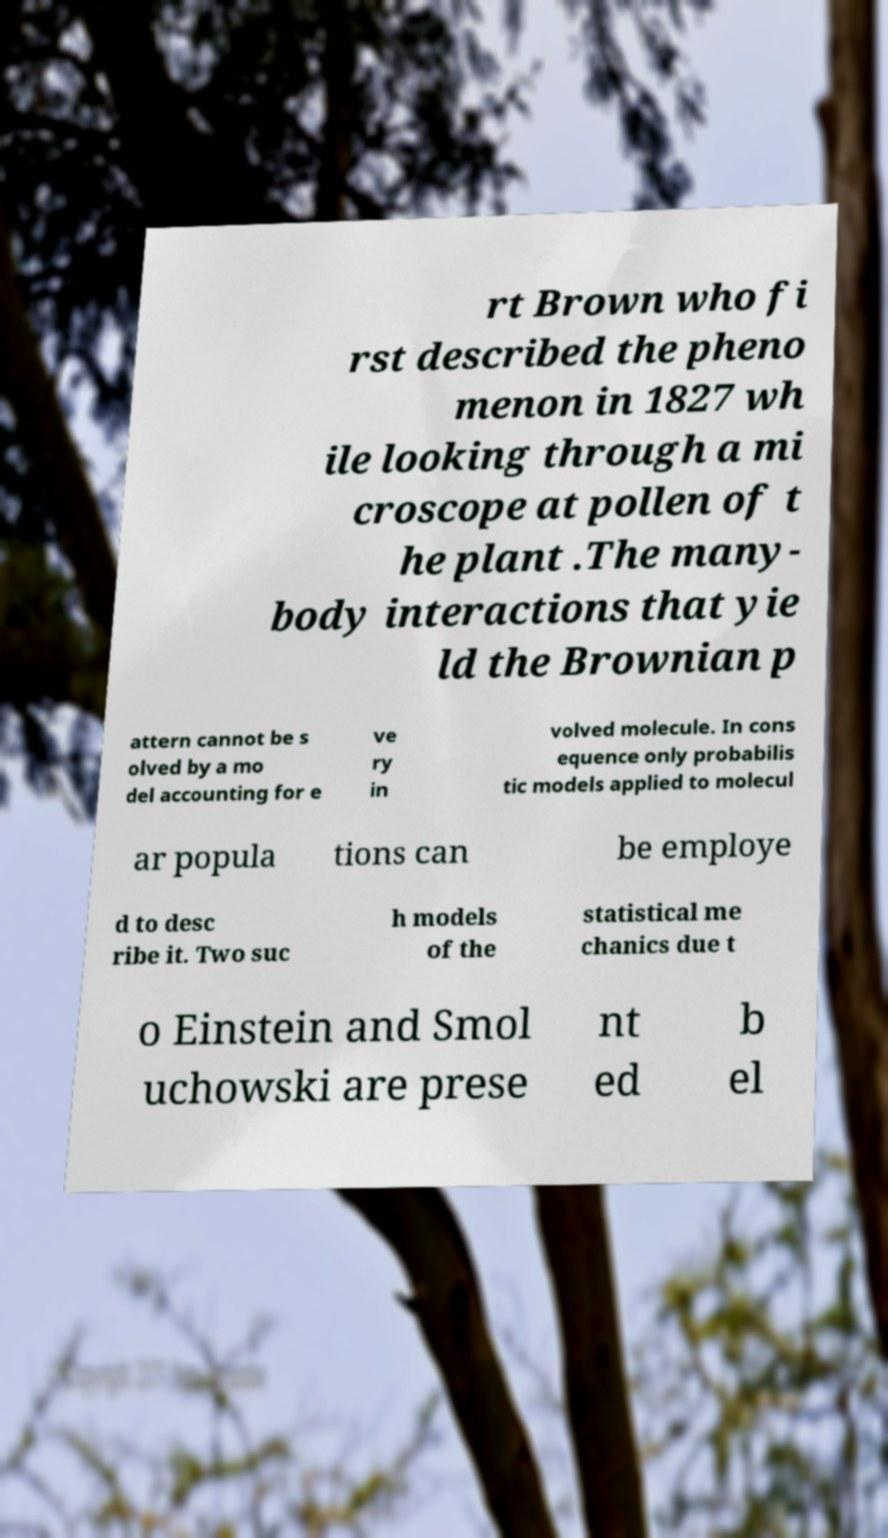Could you extract and type out the text from this image? rt Brown who fi rst described the pheno menon in 1827 wh ile looking through a mi croscope at pollen of t he plant .The many- body interactions that yie ld the Brownian p attern cannot be s olved by a mo del accounting for e ve ry in volved molecule. In cons equence only probabilis tic models applied to molecul ar popula tions can be employe d to desc ribe it. Two suc h models of the statistical me chanics due t o Einstein and Smol uchowski are prese nt ed b el 